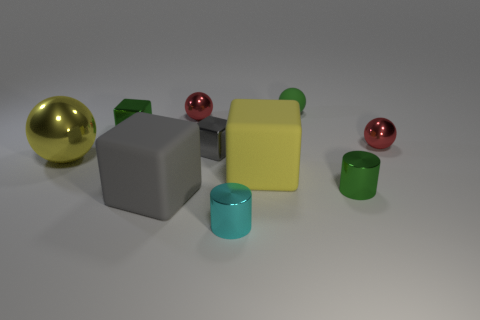There is a block right of the cyan shiny cylinder; is its size the same as the tiny cyan metal cylinder?
Offer a very short reply. No. How many other objects are the same shape as the small cyan shiny object?
Provide a short and direct response. 1. There is a big thing that is the same shape as the small rubber object; what is it made of?
Give a very brief answer. Metal. There is a big object that is on the right side of the red thing that is on the left side of the small gray block; what number of green shiny things are on the right side of it?
Offer a terse response. 1. Are there fewer tiny objects behind the small gray metal cube than metal objects behind the small cyan object?
Your response must be concise. Yes. How many other objects are the same material as the green ball?
Give a very brief answer. 2. What is the material of the ball that is the same size as the gray matte thing?
Keep it short and to the point. Metal. How many cyan things are either cylinders or big rubber cubes?
Give a very brief answer. 1. What color is the thing that is both on the left side of the tiny gray cube and in front of the large yellow matte object?
Offer a terse response. Gray. Do the small red object on the right side of the cyan metallic thing and the small green object that is in front of the yellow sphere have the same material?
Keep it short and to the point. Yes. 